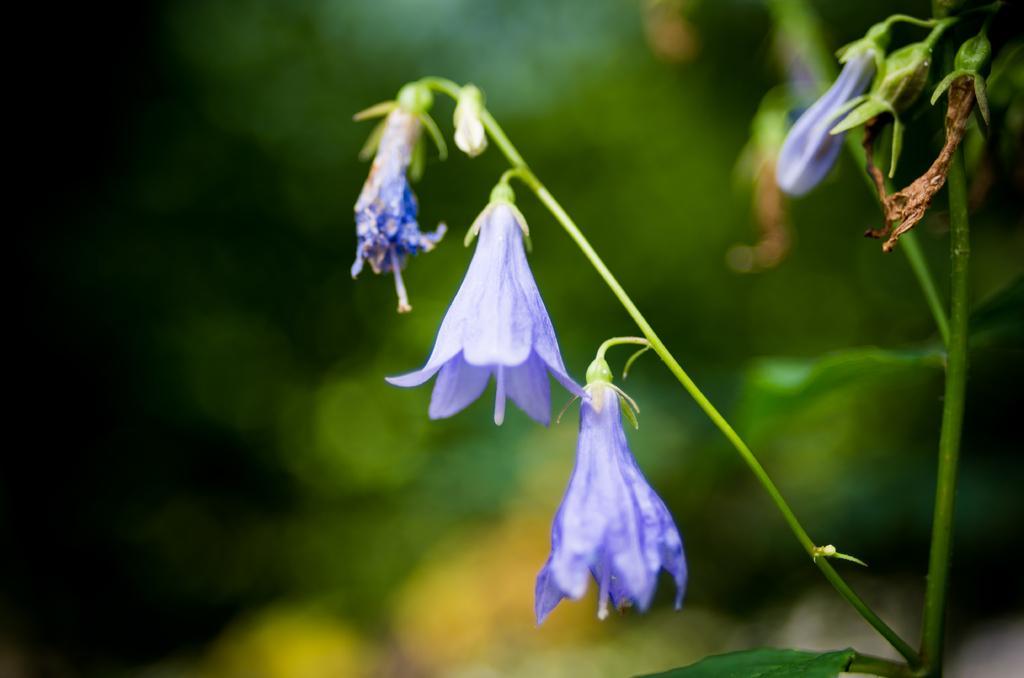Could you give a brief overview of what you see in this image? In the picture I can see the flowering plant on the right side. 